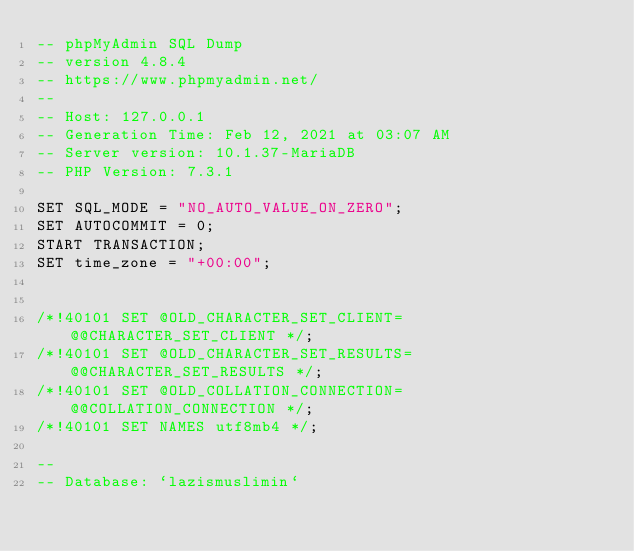Convert code to text. <code><loc_0><loc_0><loc_500><loc_500><_SQL_>-- phpMyAdmin SQL Dump
-- version 4.8.4
-- https://www.phpmyadmin.net/
--
-- Host: 127.0.0.1
-- Generation Time: Feb 12, 2021 at 03:07 AM
-- Server version: 10.1.37-MariaDB
-- PHP Version: 7.3.1

SET SQL_MODE = "NO_AUTO_VALUE_ON_ZERO";
SET AUTOCOMMIT = 0;
START TRANSACTION;
SET time_zone = "+00:00";


/*!40101 SET @OLD_CHARACTER_SET_CLIENT=@@CHARACTER_SET_CLIENT */;
/*!40101 SET @OLD_CHARACTER_SET_RESULTS=@@CHARACTER_SET_RESULTS */;
/*!40101 SET @OLD_COLLATION_CONNECTION=@@COLLATION_CONNECTION */;
/*!40101 SET NAMES utf8mb4 */;

--
-- Database: `lazismuslimin`</code> 